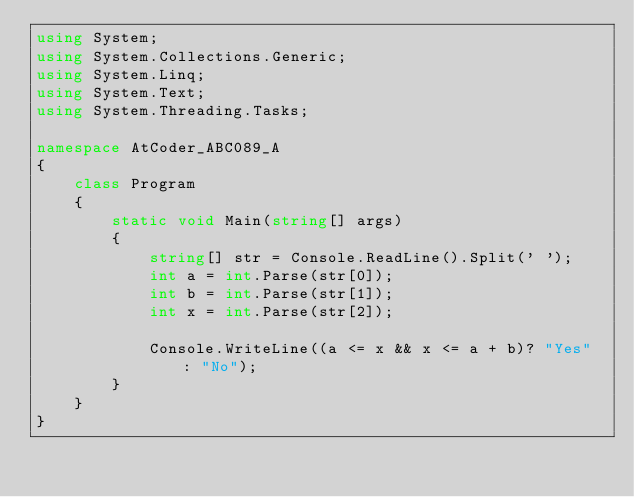<code> <loc_0><loc_0><loc_500><loc_500><_C#_>using System;
using System.Collections.Generic;
using System.Linq;
using System.Text;
using System.Threading.Tasks;

namespace AtCoder_ABC089_A
{
    class Program
    {
        static void Main(string[] args)
        {
            string[] str = Console.ReadLine().Split(' ');
            int a = int.Parse(str[0]);
            int b = int.Parse(str[1]);
            int x = int.Parse(str[2]);

            Console.WriteLine((a <= x && x <= a + b)? "Yes" : "No");
        }
    }
}
</code> 